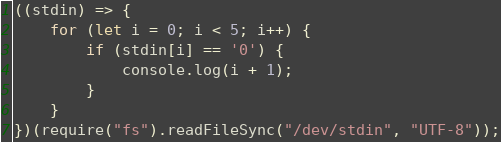<code> <loc_0><loc_0><loc_500><loc_500><_JavaScript_>((stdin) => {
	for (let i = 0; i < 5; i++) {
		if (stdin[i] == '0') {
			console.log(i + 1);
		}
	}
})(require("fs").readFileSync("/dev/stdin", "UTF-8"));</code> 